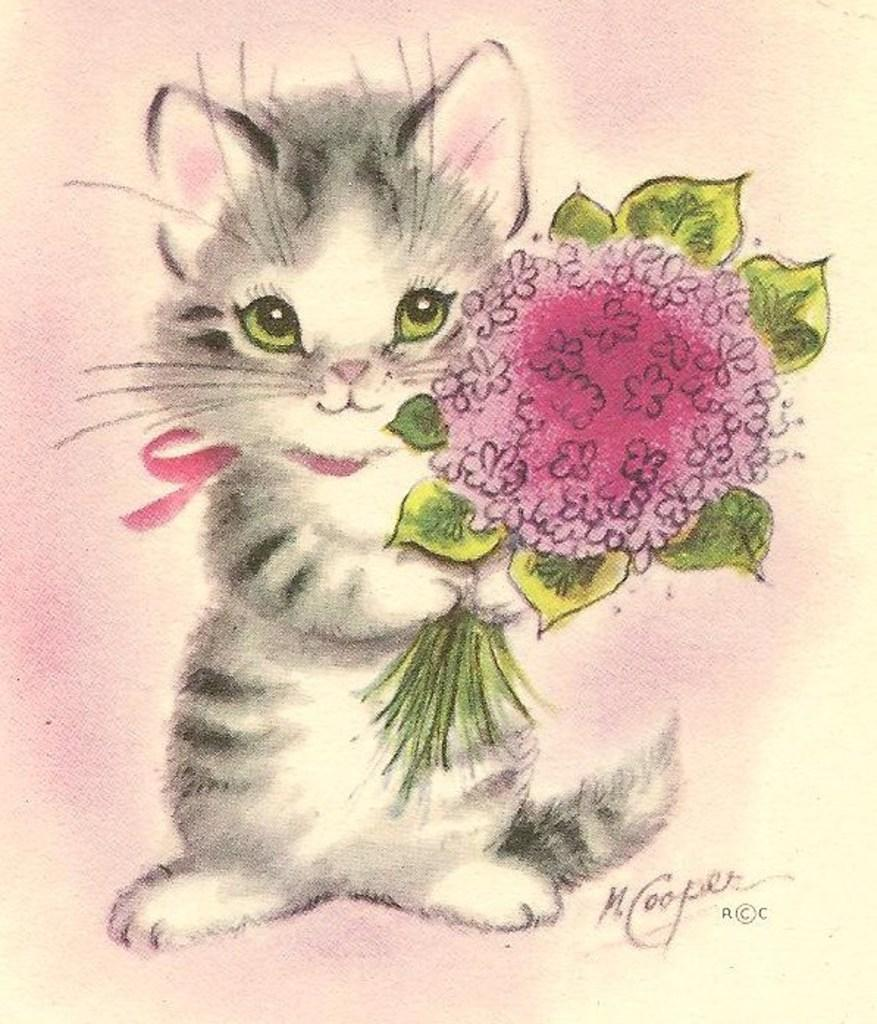What type of artwork is depicted in the image? The image appears to be a painting. What animal is featured in the painting? There is a cat in the painting. What is the cat holding in the painting? The cat is holding a bouquet. Are there any words or letters in the painting? Yes, there is text present in the painting. How would you describe the background of the painting? The background of the painting is colorful. Can you hear the toad whistling in the painting? There is no toad or whistling present in the painting; it features a cat holding a bouquet and has text and a colorful background. 